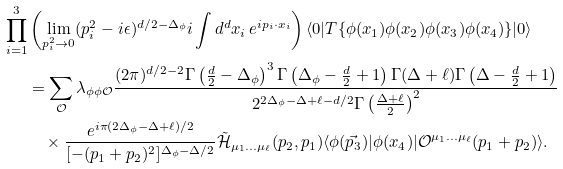Convert formula to latex. <formula><loc_0><loc_0><loc_500><loc_500>\prod _ { i = 1 } ^ { 3 } & \left ( \lim _ { p _ { i } ^ { 2 } \to 0 } ( p _ { i } ^ { 2 } - i \epsilon ) ^ { d / 2 - \Delta _ { \phi } } i \int d ^ { d } x _ { i } \, e ^ { i p _ { i } \cdot x _ { i } } \right ) \langle 0 | T \{ \phi ( x _ { 1 } ) \phi ( x _ { 2 } ) \phi ( x _ { 3 } ) \phi ( x _ { 4 } ) \} | 0 \rangle \\ & = \sum _ { \mathcal { O } } \lambda _ { \phi \phi \mathcal { O } } \frac { ( 2 \pi ) ^ { d / 2 - 2 } \Gamma \left ( \frac { d } { 2 } - \Delta _ { \phi } \right ) ^ { 3 } \Gamma \left ( \Delta _ { \phi } - \frac { d } { 2 } + 1 \right ) \Gamma ( \Delta + \ell ) \Gamma \left ( \Delta - \frac { d } { 2 } + 1 \right ) } { 2 ^ { 2 \Delta _ { \phi } - \Delta + \ell - d / 2 } \Gamma \left ( \frac { \Delta + \ell } { 2 } \right ) ^ { 2 } } \\ & \quad \times \frac { e ^ { i \pi ( 2 \Delta _ { \phi } - \Delta + \ell ) / 2 } } { [ - ( p _ { 1 } + p _ { 2 } ) ^ { 2 } ] ^ { \Delta _ { \phi } - \Delta / 2 } } \tilde { \mathcal { H } } _ { \mu _ { 1 } \dots \mu _ { \ell } } ( p _ { 2 } , p _ { 1 } ) \langle \phi ( \vec { p } _ { 3 } ) | \phi ( x _ { 4 } ) | \mathcal { O } ^ { \mu _ { 1 } \dots \mu _ { \ell } } ( p _ { 1 } + p _ { 2 } ) \rangle .</formula> 